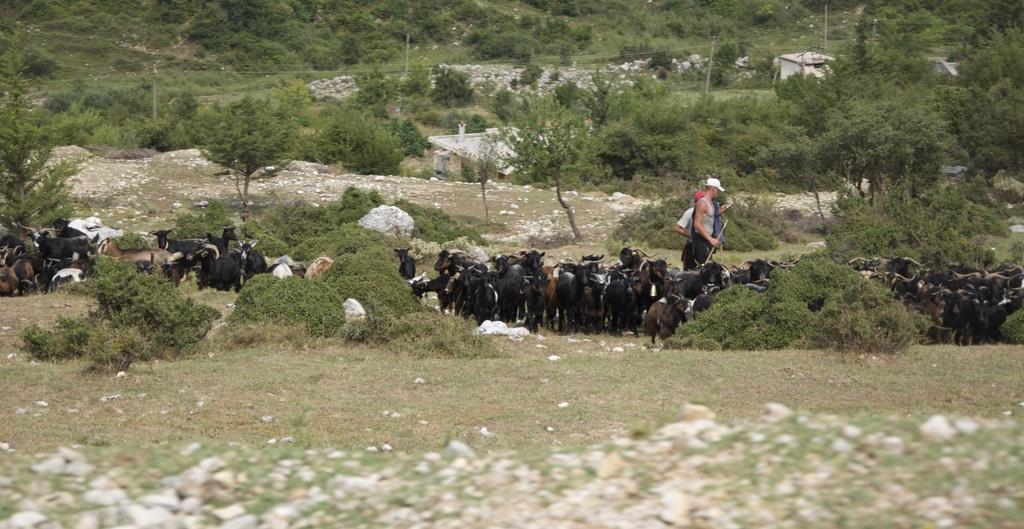What animals are present in the image? There is a group of goats in the image. How many people are in the image? There are two persons in the image. What object can be seen in the image that might be used for support or guidance? There is a stick in the image. What type of terrain is visible in the image? There are stones on the ground in the image. What structures can be seen in the background of the image? There is a shed and poles in the background of the image. What type of natural environment is visible in the background of the image? There are trees in the background of the image. Can you describe any other objects or features in the background of the image? There are some unspecified objects in the background of the image. How many ants are crawling on the goats in the image? There are no ants visible in the image; it only shows a group of goats, two persons, a stick, stones, a shed, poles, trees, and unspecified objects in the background. 